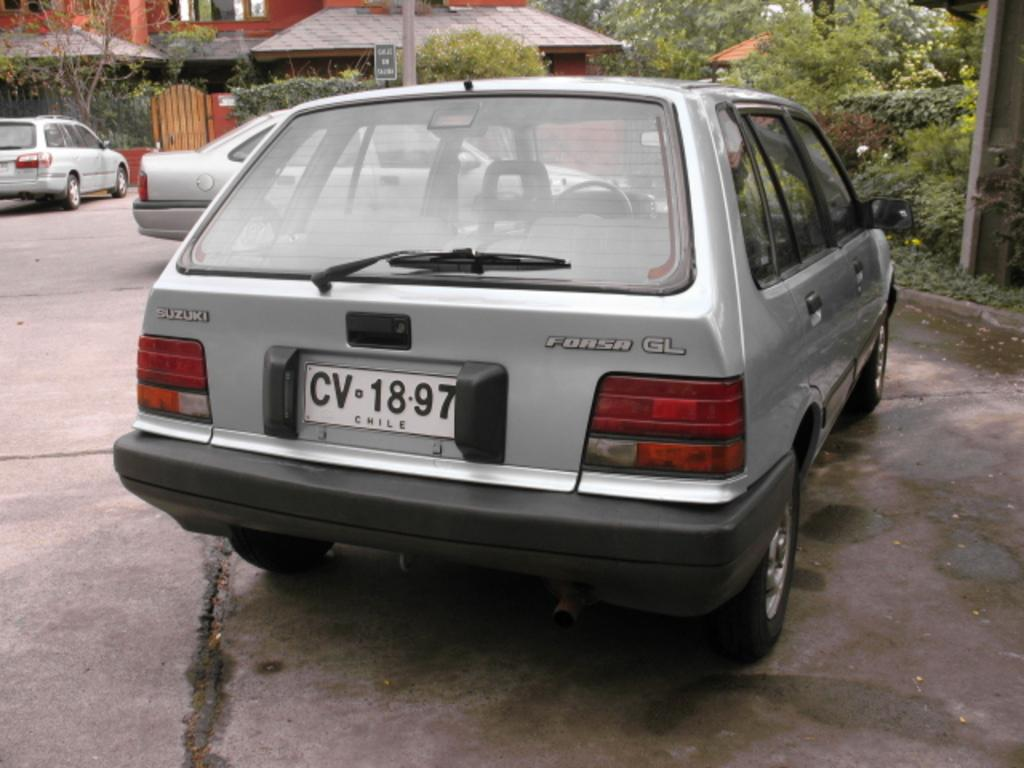<image>
Share a concise interpretation of the image provided. A silver colored car that is registered in Chile is parked. 